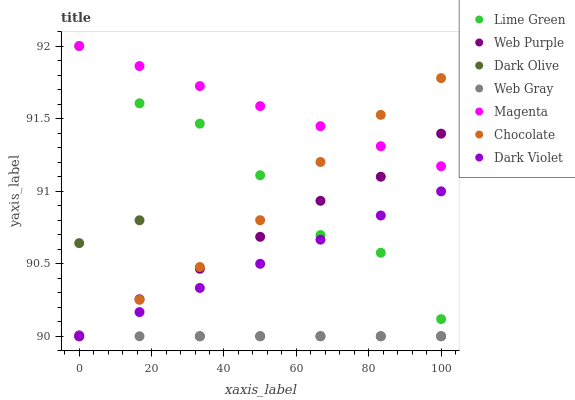Does Web Gray have the minimum area under the curve?
Answer yes or no. Yes. Does Magenta have the maximum area under the curve?
Answer yes or no. Yes. Does Dark Olive have the minimum area under the curve?
Answer yes or no. No. Does Dark Olive have the maximum area under the curve?
Answer yes or no. No. Is Web Gray the smoothest?
Answer yes or no. Yes. Is Dark Olive the roughest?
Answer yes or no. Yes. Is Dark Violet the smoothest?
Answer yes or no. No. Is Dark Violet the roughest?
Answer yes or no. No. Does Web Gray have the lowest value?
Answer yes or no. Yes. Does Web Purple have the lowest value?
Answer yes or no. No. Does Lime Green have the highest value?
Answer yes or no. Yes. Does Dark Olive have the highest value?
Answer yes or no. No. Is Dark Violet less than Magenta?
Answer yes or no. Yes. Is Lime Green greater than Dark Olive?
Answer yes or no. Yes. Does Dark Olive intersect Chocolate?
Answer yes or no. Yes. Is Dark Olive less than Chocolate?
Answer yes or no. No. Is Dark Olive greater than Chocolate?
Answer yes or no. No. Does Dark Violet intersect Magenta?
Answer yes or no. No. 